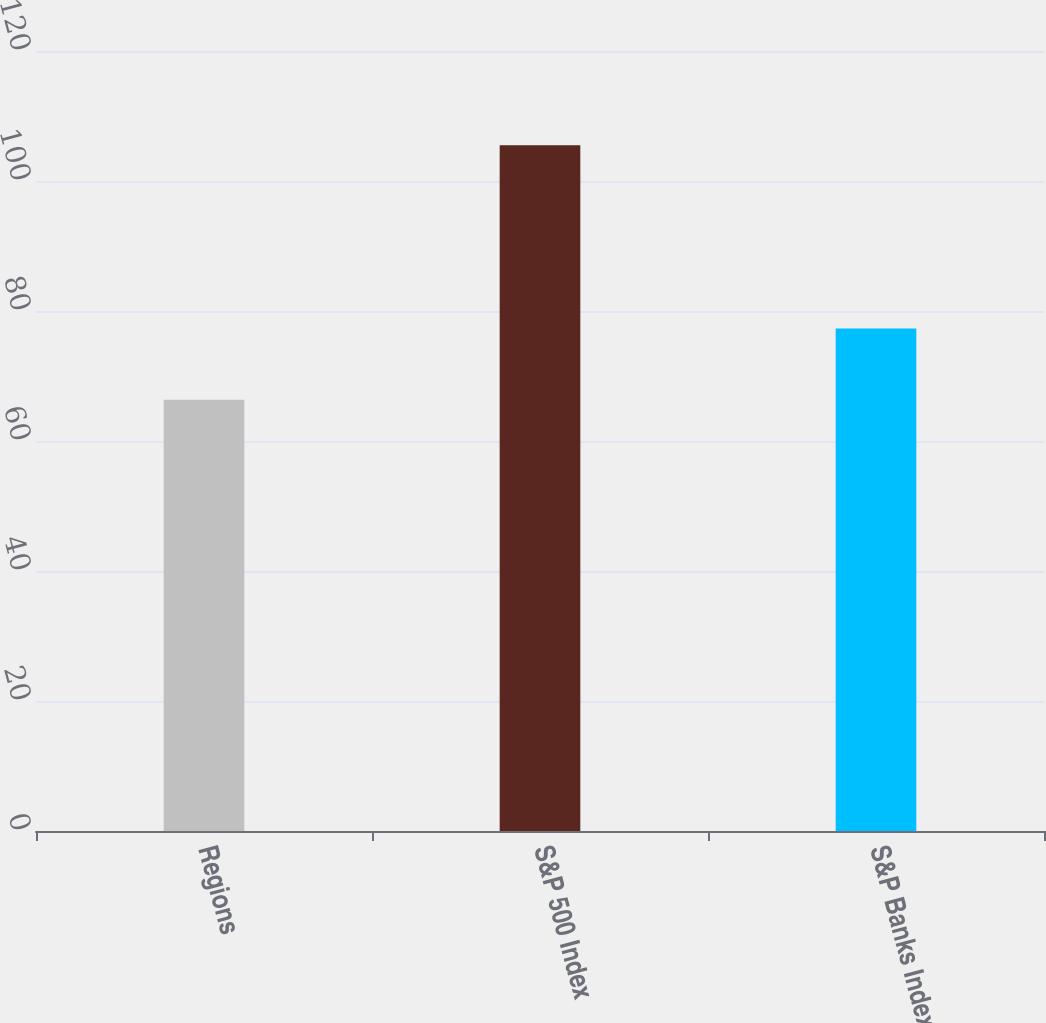Convert chart to OTSL. <chart><loc_0><loc_0><loc_500><loc_500><bar_chart><fcel>Regions<fcel>S&P 500 Index<fcel>S&P Banks Index<nl><fcel>66.36<fcel>105.49<fcel>77.32<nl></chart> 